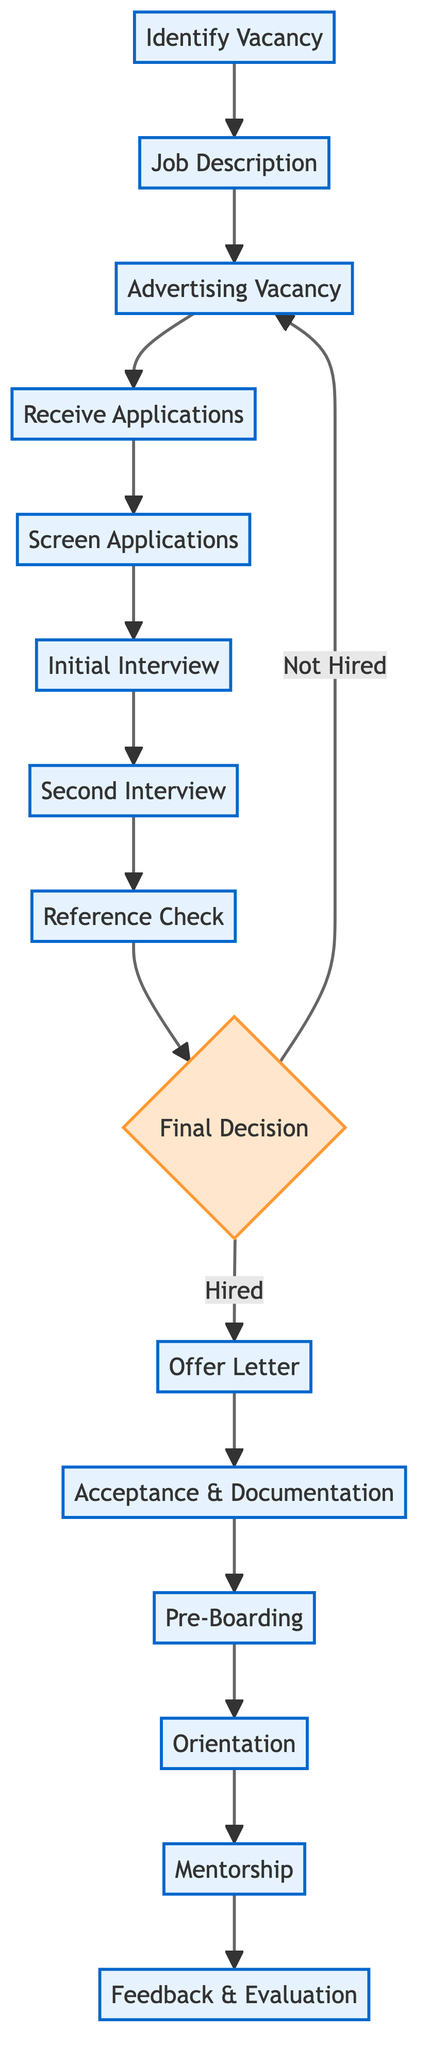What is the first step in the process? The first step in the flowchart is "Identify Vacancy," which signifies the beginning of the teacher recruitment process by determining the need for a new teacher.
Answer: Identify Vacancy How many total steps are in the diagram? The diagram contains 15 distinct steps, encompassing the whole teacher recruitment and onboarding process from identifying the vacancy to feedback and evaluation.
Answer: 15 Which step comes directly after "Screen Applications"? The step that comes directly after "Screen Applications" is "Initial Interview," indicating that once applications are screened, initial interviews are conducted with shortlisted candidates.
Answer: Initial Interview What happens if the decision from the "Final Decision" is "Not Hired"? If the decision is "Not Hired," the process loops back to "Advertising Vacancy," implying that the position is re-advertised for other candidates until a suitable one is found.
Answer: Advertising Vacancy What is the last step of the process? The last step of the process is "Feedback & Evaluation," which concludes the onboarding by assessing the new teacher's performance and offering constructive feedback.
Answer: Feedback & Evaluation What is the relationship between "Second Interview" and "Reference Check"? "Second Interview" is a precursor to "Reference Check," as the reference checks are only conducted after candidates have been invited for a second interview.
Answer: Second Interview → Reference Check How is "Mentorship" related to "Orientation"? "Mentorship" is a subsequent step that follows "Orientation," indicating that after the orientation session, a mentor is assigned to provide ongoing support to the new teacher.
Answer: Orientation → Mentorship What is included in the "Pre-Boarding" process? The "Pre-Boarding" phase includes providing new hires with essential materials such as school policies, curriculum guides, and classroom resources to prepare them before their first day.
Answer: School policies, curriculum guides, classroom resources 